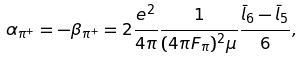<formula> <loc_0><loc_0><loc_500><loc_500>\alpha _ { \pi ^ { + } } = - \beta _ { \pi ^ { + } } = 2 \frac { e ^ { 2 } } { 4 \pi } \frac { 1 } { ( 4 \pi F _ { \pi } ) ^ { 2 } \mu } \frac { \bar { l } _ { 6 } - \bar { l } _ { 5 } } { 6 } ,</formula> 